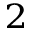Convert formula to latex. <formula><loc_0><loc_0><loc_500><loc_500>^ { 2 }</formula> 